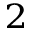Convert formula to latex. <formula><loc_0><loc_0><loc_500><loc_500>^ { 2 }</formula> 